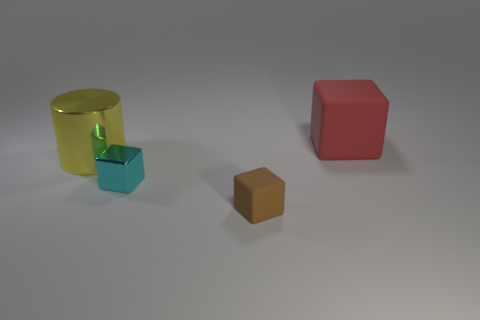Subtract all small blocks. How many blocks are left? 1 Add 2 tiny cyan metal objects. How many objects exist? 6 Subtract 1 blocks. How many blocks are left? 2 Subtract all cubes. How many objects are left? 1 Subtract all small cyan metal blocks. Subtract all big red blocks. How many objects are left? 2 Add 4 big matte cubes. How many big matte cubes are left? 5 Add 2 big yellow shiny cylinders. How many big yellow shiny cylinders exist? 3 Subtract 0 blue cylinders. How many objects are left? 4 